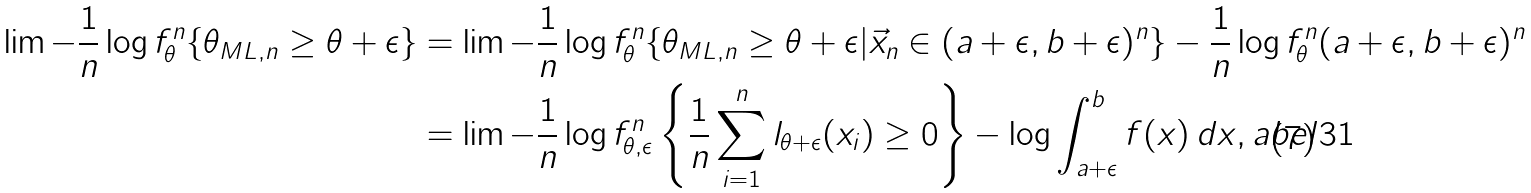Convert formula to latex. <formula><loc_0><loc_0><loc_500><loc_500>\lim - \frac { 1 } { n } \log f _ { \theta } ^ { n } \{ \theta _ { M L , n } \geq \theta + \epsilon \} & = \lim - \frac { 1 } { n } \log f _ { \theta } ^ { n } \{ \theta _ { M L , n } \geq \theta + \epsilon | \vec { x } _ { n } \in ( a + \epsilon , b + \epsilon ) ^ { n } \} - \frac { 1 } { n } \log f ^ { n } _ { \theta } ( a + \epsilon , b + \epsilon ) ^ { n } \\ & = \lim - \frac { 1 } { n } \log f _ { \theta , \epsilon } ^ { n } \left \{ \frac { 1 } { n } \sum _ { i = 1 } ^ { n } l _ { \theta + \epsilon } ( x _ { i } ) \geq 0 \right \} - \log \int _ { a + \epsilon } ^ { b } f ( x ) \, d x , \L a b e l { 3 1 }</formula> 